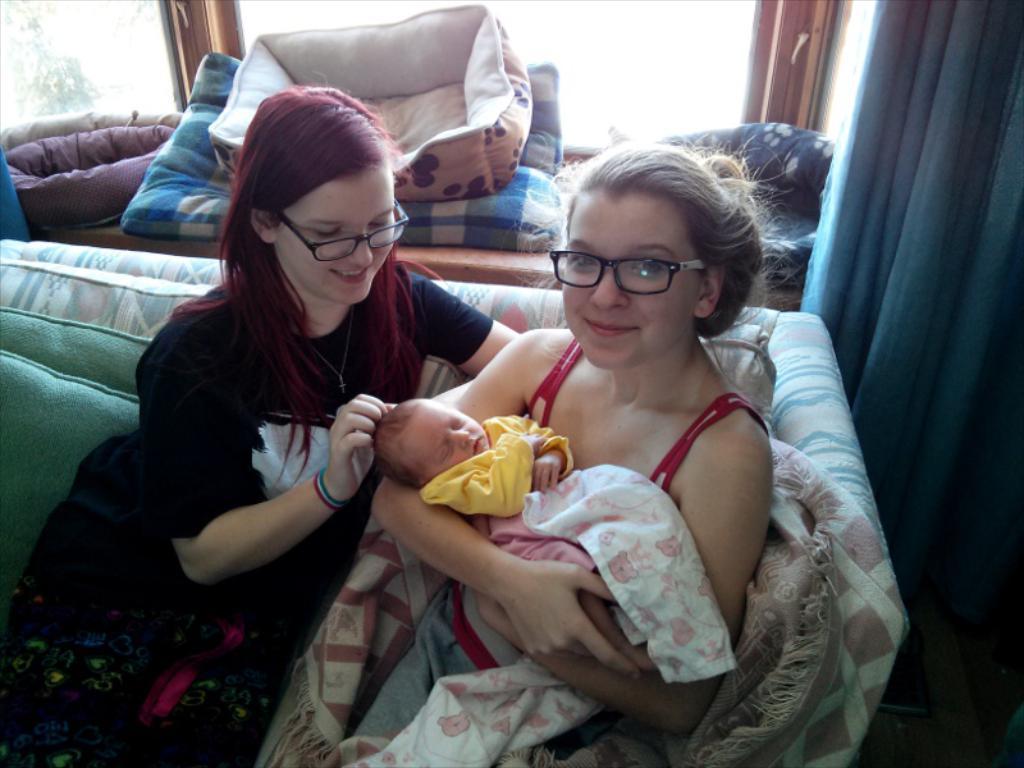Could you give a brief overview of what you see in this image? This image consists of two women holding a kid. They are sitting in a sofa. To the right, there is a curtain. In the background, there is a window along with pillows. 